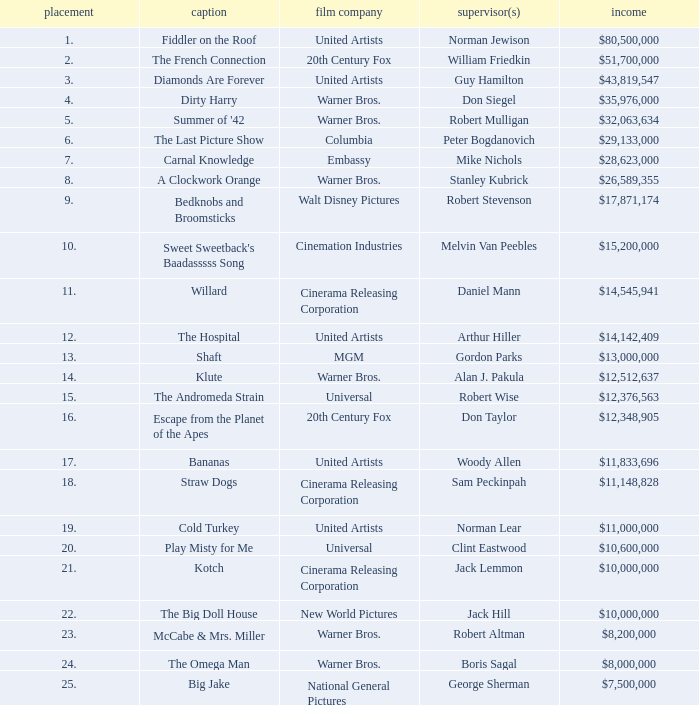What position does the title hold with a total revenue of $26,589,355? 8.0. 